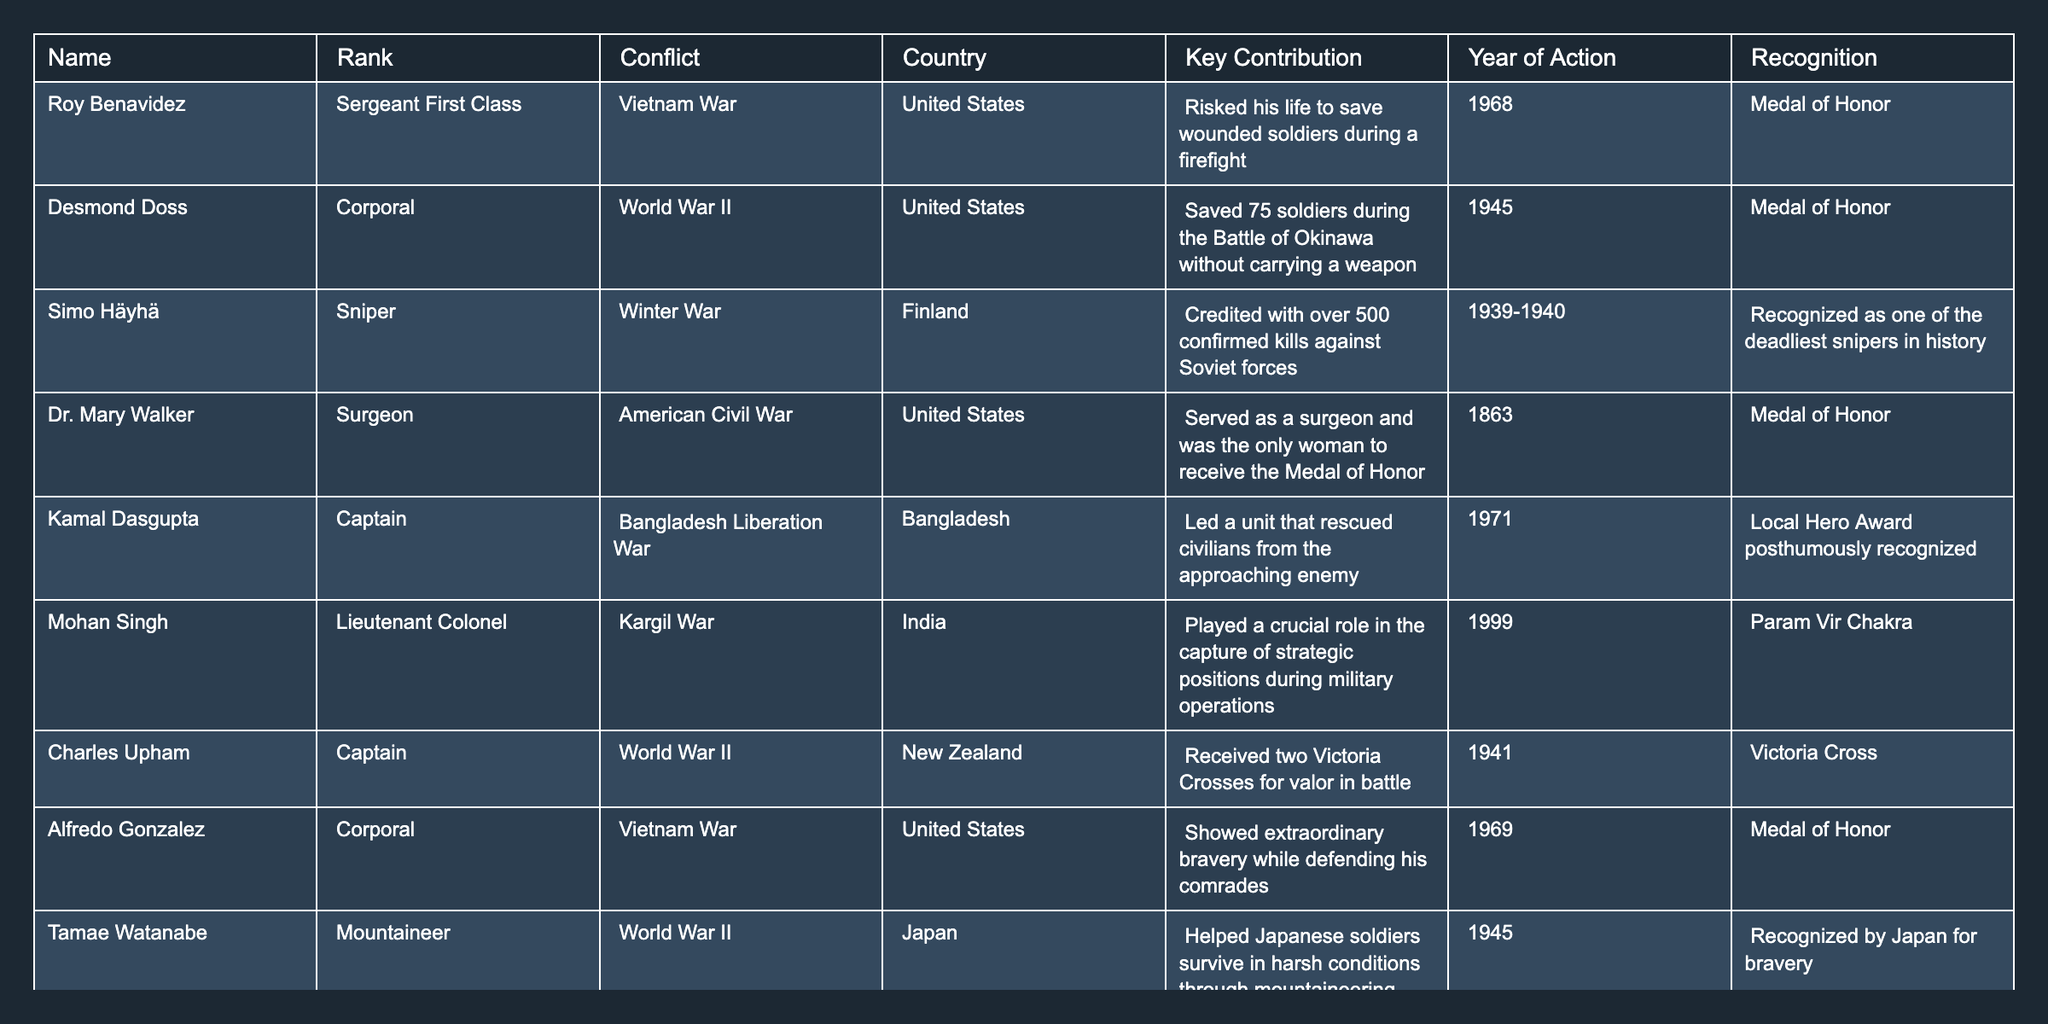What was the key contribution of Desmond Doss? According to the table, Desmond Doss saved 75 soldiers during the Battle of Okinawa without carrying a weapon.
Answer: Saved 75 soldiers during the Battle of Okinawa without carrying a weapon How many war heroes received the Medal of Honor? The table shows that four individuals received the Medal of Honor: Roy Benavidez, Desmond Doss, Dr. Mary Walker, and Alfredo Gonzalez.
Answer: Four Which country did Kamal Dasgupta contribute to during the Bangladesh Liberation War? The table indicates that Kamal Dasgupta contributed to the Bangladesh Liberation War which took place in Bangladesh.
Answer: Bangladesh Who is recognized as one of the deadliest snipers in history? According to the table, Simo Häyhä is recognized as one of the deadliest snipers in history.
Answer: Simo Häyhä What year did Mohan Singh contribute to the Kargil War? The table states that Mohan Singh played a crucial role in the Kargil War in the year 1999.
Answer: 1999 Did any of the heroes serve in World War II? The table confirms that Desmond Doss and Charles Upham served in World War II.
Answer: Yes Which two heroes received the highest level of recognition in the form of a Victoria Cross? Charles Upham is the only individual in the table who received two Victoria Crosses for valor in battle.
Answer: Charles Upham How many unsung heroes contributed to wars before the 20th century? The table displays only one unsung hero from before the 20th century, Dr. Mary Walker, who served during the American Civil War in 1863.
Answer: One Which hero was a surgeon during the American Civil War? The table attributes the profession of a surgeon during the American Civil War to Dr. Mary Walker.
Answer: Dr. Mary Walker What is the total number of countries represented in the table? The table displays war heroes from five different countries: United States, Finland, Bangladesh, India, and New Zealand.
Answer: Five Which hero's contribution involved mountaineering skills? Tamae Watanabe's contribution involved mountaineering skills to help Japanese soldiers survive during World War II.
Answer: Tamae Watanabe What was the nature of Kamal Dasgupta's recognition? The table indicates that Kamal Dasgupta was recognized as a Local Hero posthumously for his contributions during the Bangladesh Liberation War.
Answer: Local Hero Award posthumously recognized 